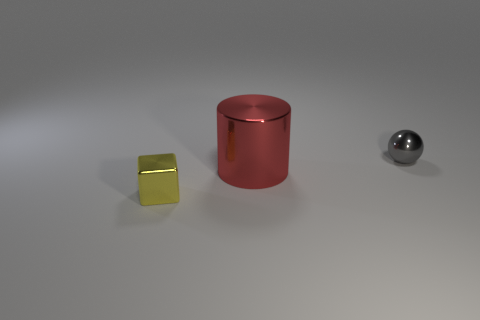How many tiny objects are brown cylinders or red shiny objects?
Your response must be concise. 0. The yellow thing that is the same size as the gray shiny object is what shape?
Keep it short and to the point. Cube. Are there any other things that have the same size as the sphere?
Your answer should be very brief. Yes. What material is the tiny thing that is in front of the tiny metallic thing that is on the right side of the tiny yellow shiny block?
Your answer should be very brief. Metal. Is the yellow block the same size as the cylinder?
Keep it short and to the point. No. What number of objects are either things behind the yellow metal object or tiny gray rubber cubes?
Offer a terse response. 2. The small metal thing on the right side of the tiny metallic thing that is in front of the tiny ball is what shape?
Give a very brief answer. Sphere. There is a red object; does it have the same size as the metallic object left of the big cylinder?
Provide a succinct answer. No. What is the tiny thing that is in front of the metallic ball made of?
Your answer should be compact. Metal. How many tiny metallic objects are both in front of the large metallic cylinder and right of the large red cylinder?
Provide a short and direct response. 0. 